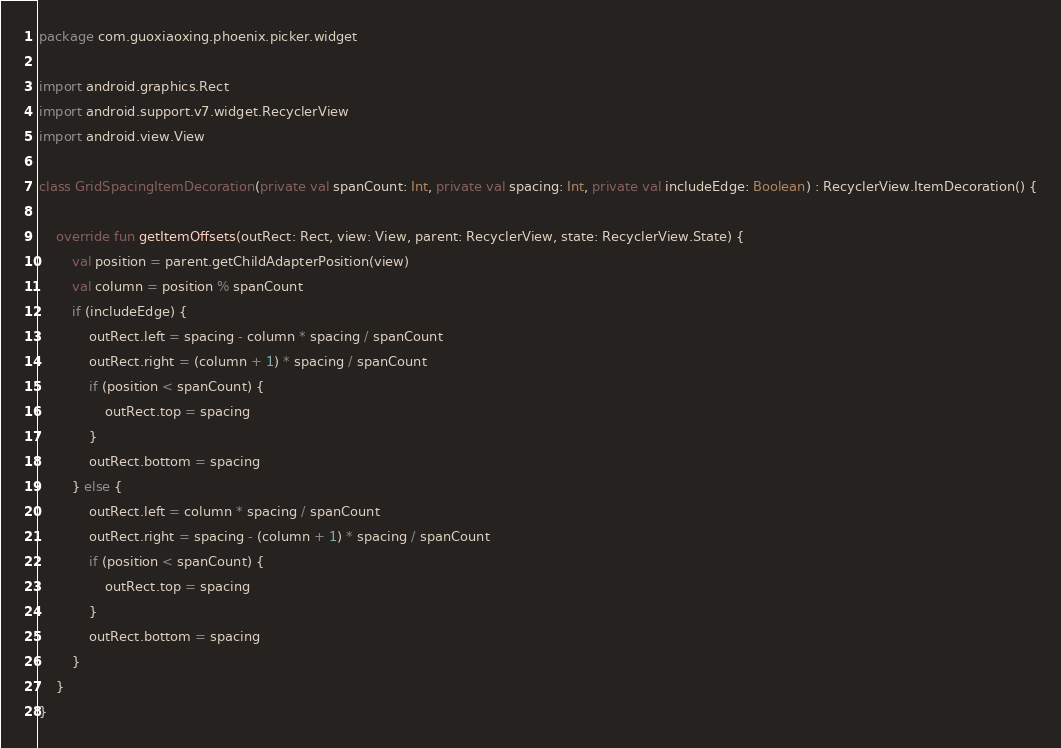<code> <loc_0><loc_0><loc_500><loc_500><_Kotlin_>package com.guoxiaoxing.phoenix.picker.widget

import android.graphics.Rect
import android.support.v7.widget.RecyclerView
import android.view.View

class GridSpacingItemDecoration(private val spanCount: Int, private val spacing: Int, private val includeEdge: Boolean) : RecyclerView.ItemDecoration() {

    override fun getItemOffsets(outRect: Rect, view: View, parent: RecyclerView, state: RecyclerView.State) {
        val position = parent.getChildAdapterPosition(view)
        val column = position % spanCount
        if (includeEdge) {
            outRect.left = spacing - column * spacing / spanCount
            outRect.right = (column + 1) * spacing / spanCount
            if (position < spanCount) {
                outRect.top = spacing
            }
            outRect.bottom = spacing
        } else {
            outRect.left = column * spacing / spanCount
            outRect.right = spacing - (column + 1) * spacing / spanCount
            if (position < spanCount) {
                outRect.top = spacing
            }
            outRect.bottom = spacing
        }
    }
}</code> 